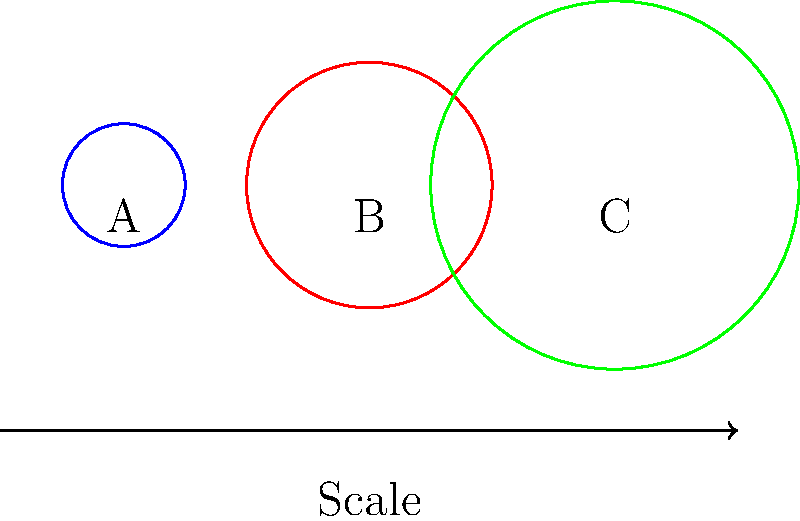In this scale diagram of three celestial bodies A, B, and C, which body has a volume closest to twice that of body B? Assume all bodies are perfect spheres. To solve this problem, we need to follow these steps:

1. Observe that the radii of the bodies are in the ratio:
   A : B : C = 1 : 2 : 3

2. Recall that the volume of a sphere is given by the formula:
   $V = \frac{4}{3}\pi r^3$

3. Calculate the relative volumes:
   $V_A : V_B : V_C = (\frac{1}{2})^3 : 1^3 : (\frac{3}{2})^3$
   
4. Simplify:
   $V_A : V_B : V_C = \frac{1}{8} : 1 : \frac{27}{8}$

5. Compare to twice the volume of B:
   $2V_B = 2$

6. Check which is closest to 2:
   $V_A = \frac{1}{8} = 0.125$ (too small)
   $V_B = 1$ (too small)
   $V_C = \frac{27}{8} = 3.375$ (closest to 2)

Therefore, body C has a volume closest to twice that of body B.
Answer: C 